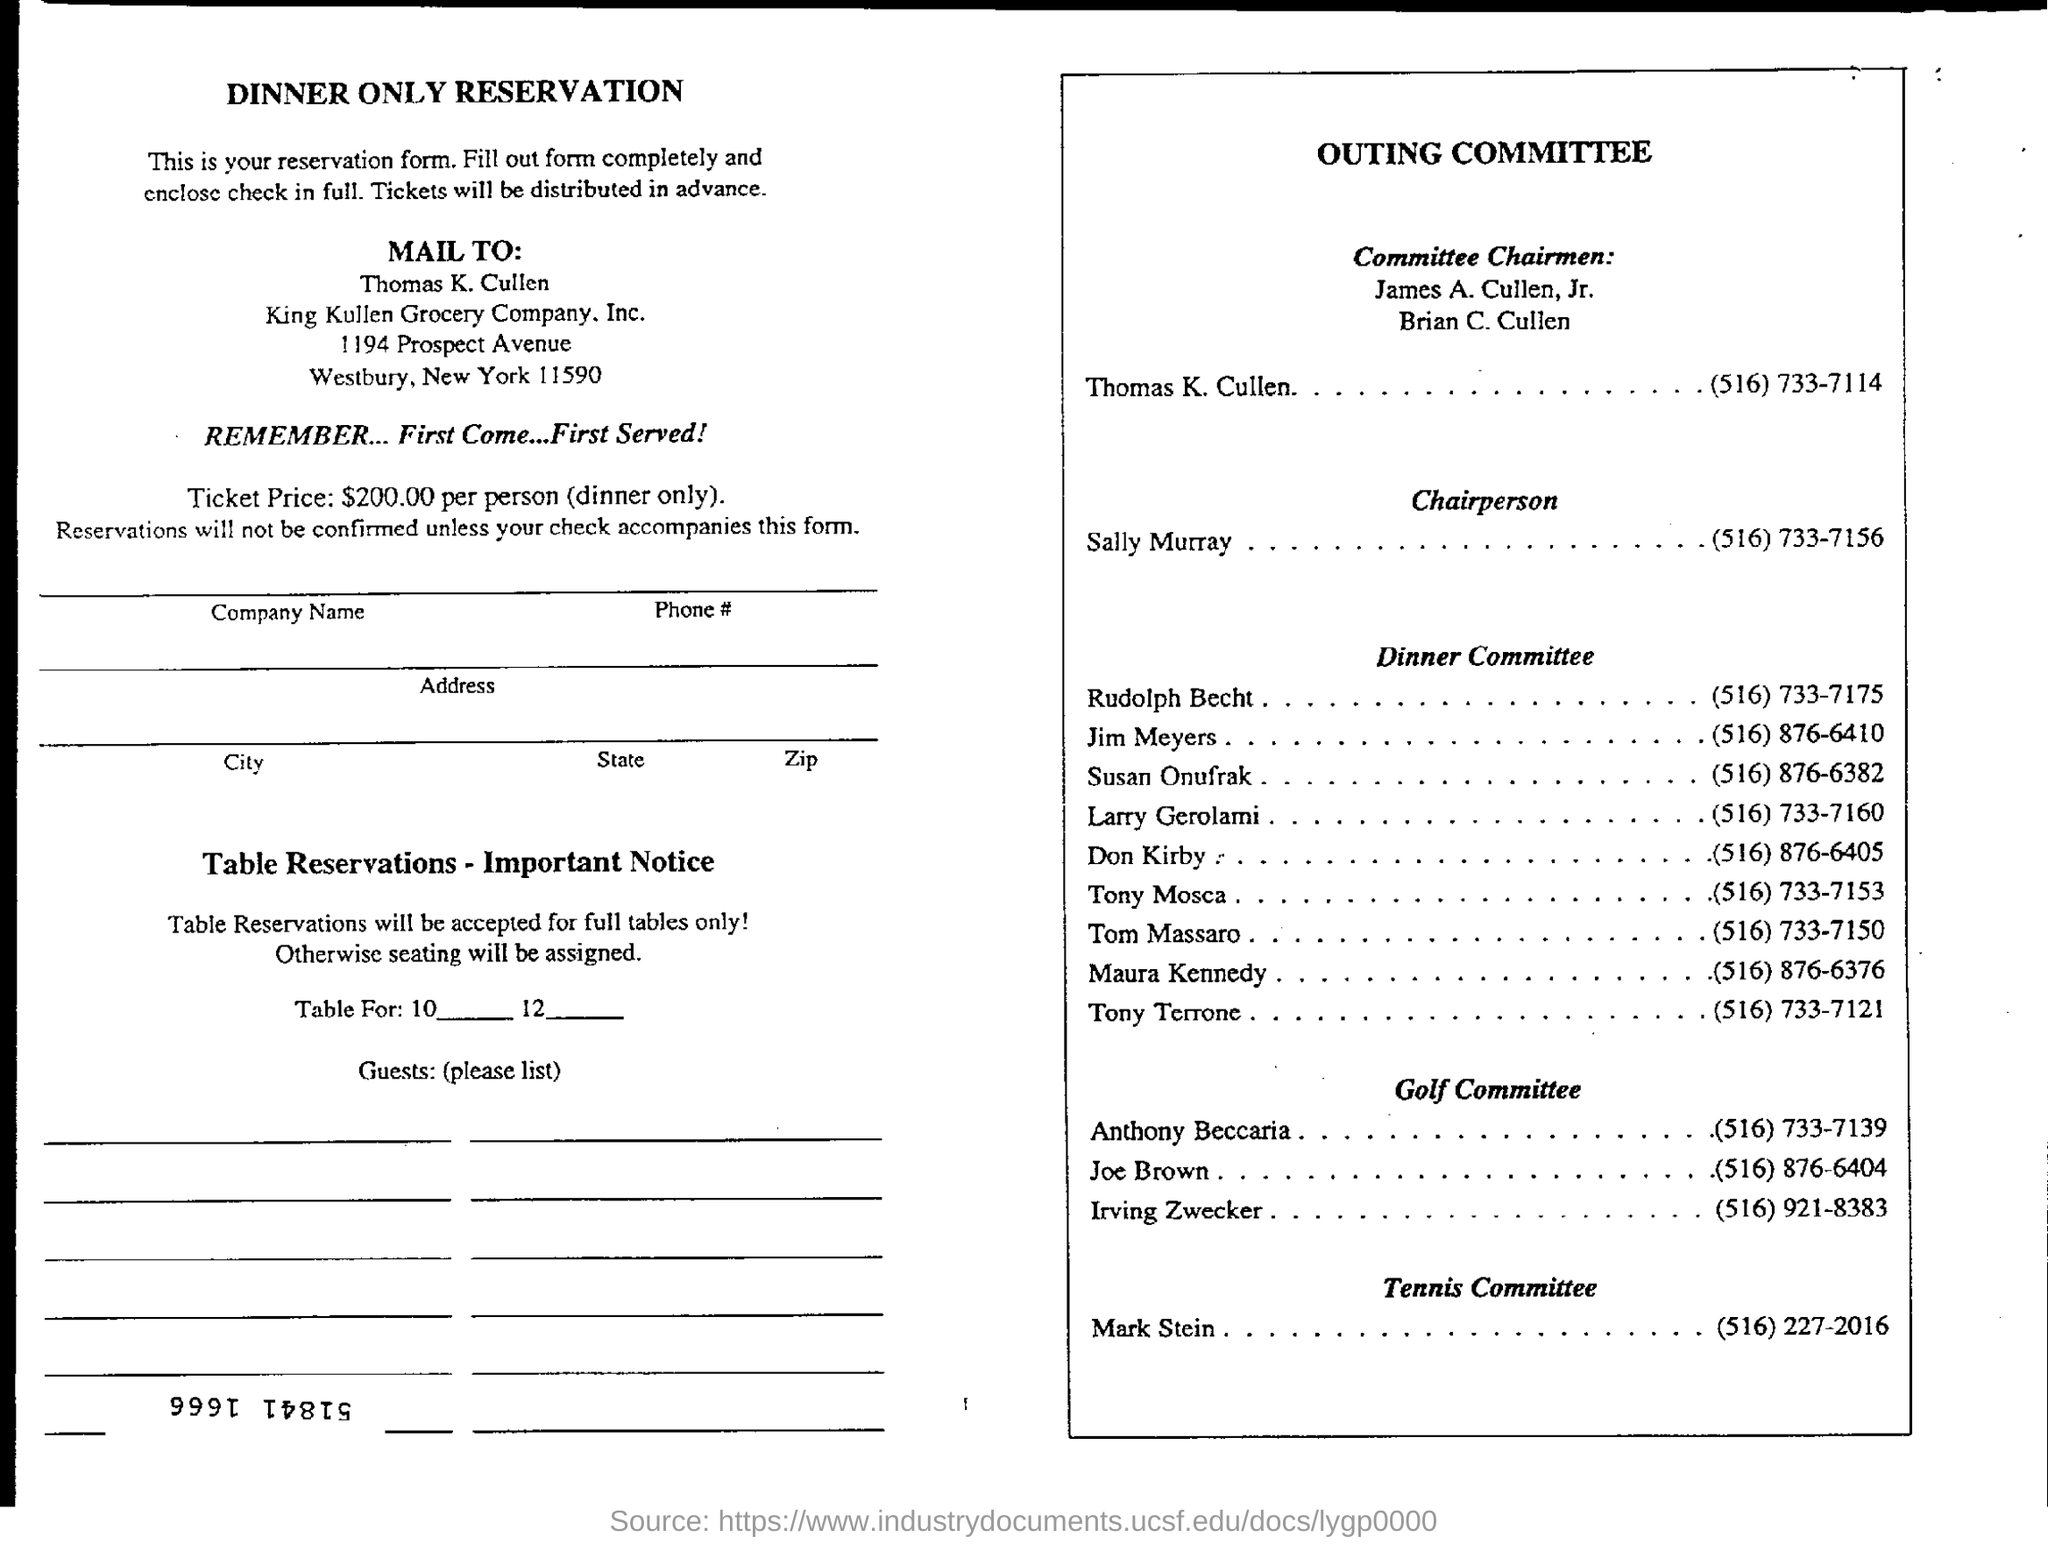How much is the price of ticket per person(dinner only)?
Your response must be concise. $200.00 per person. In which state is king kullen grocery company, inc. at ?
Provide a short and direct response. New York. What is the telephone number of sally murray ?
Your answer should be very brief. (516) 733-7156. What is the telephone number of mark stein ?
Give a very brief answer. (516) 227-2016. 